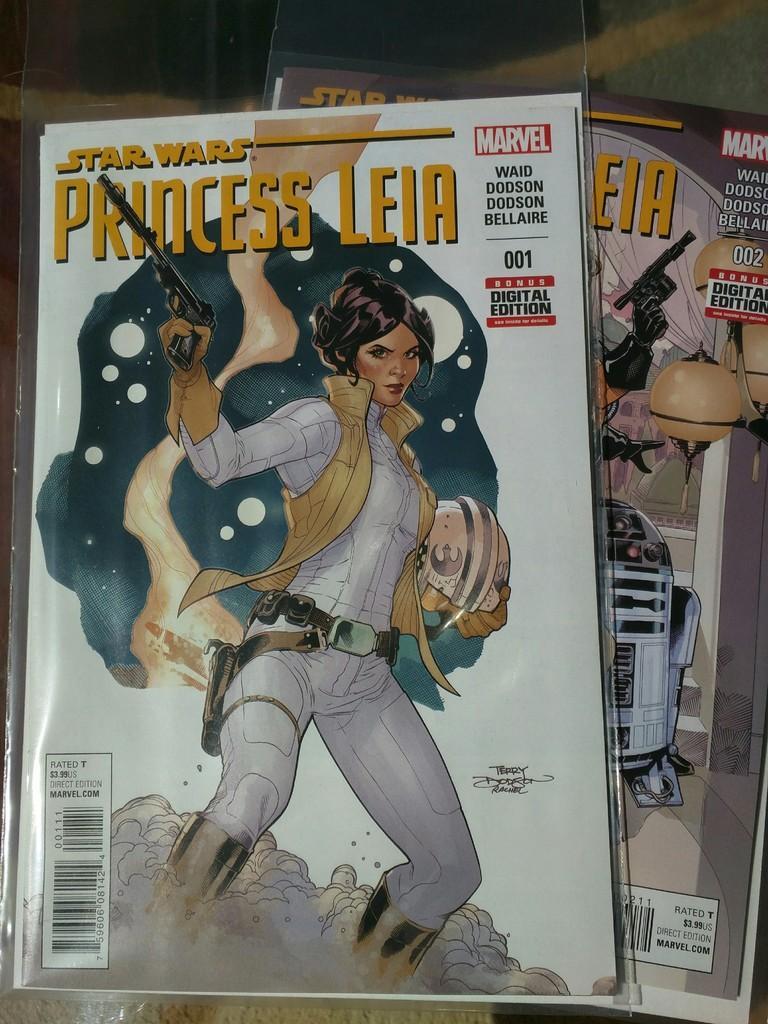In one or two sentences, can you explain what this image depicts? In this image in the center there are two books, on the books there is one woman who is standing and she is holding a gun and some text written. 